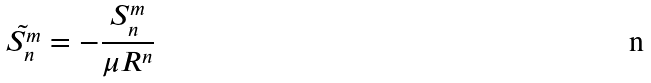Convert formula to latex. <formula><loc_0><loc_0><loc_500><loc_500>\tilde { S _ { n } ^ { m } } = - \frac { S _ { n } ^ { m } } { \mu R ^ { n } }</formula> 